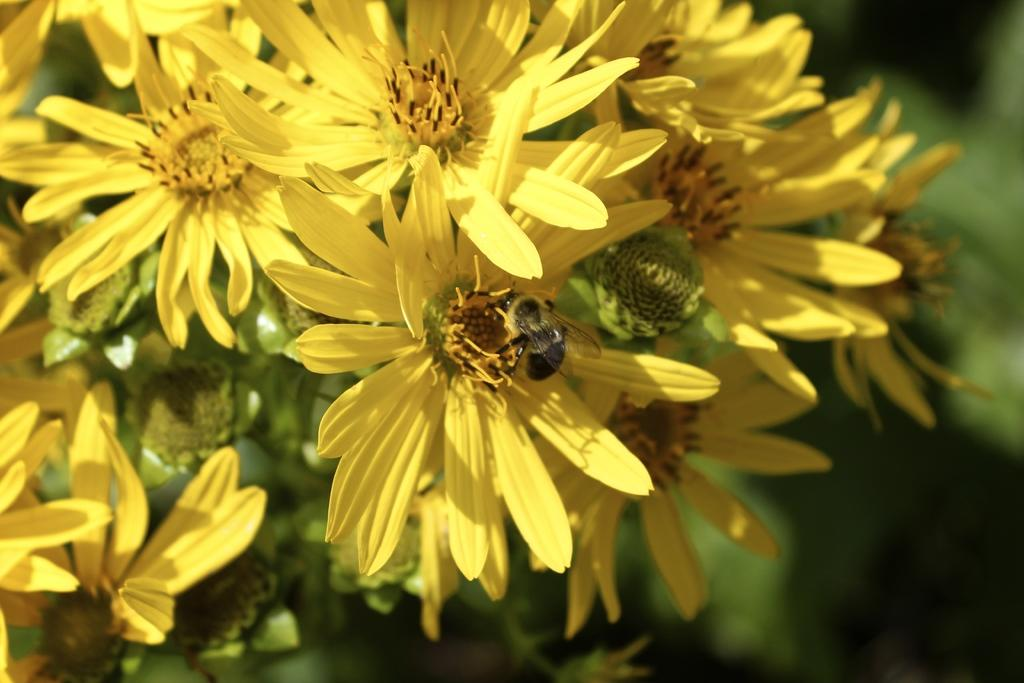What is present in the image? There are flowers in the image. Can you describe the interaction between the flowers and another element in the image? There is a honey bee on a flower. How would you describe the appearance of the background in the image? The background of the image is blurred. What type of button can be seen on the farm in the image? There is no button or farm present in the image; it features flowers and a honey bee. 